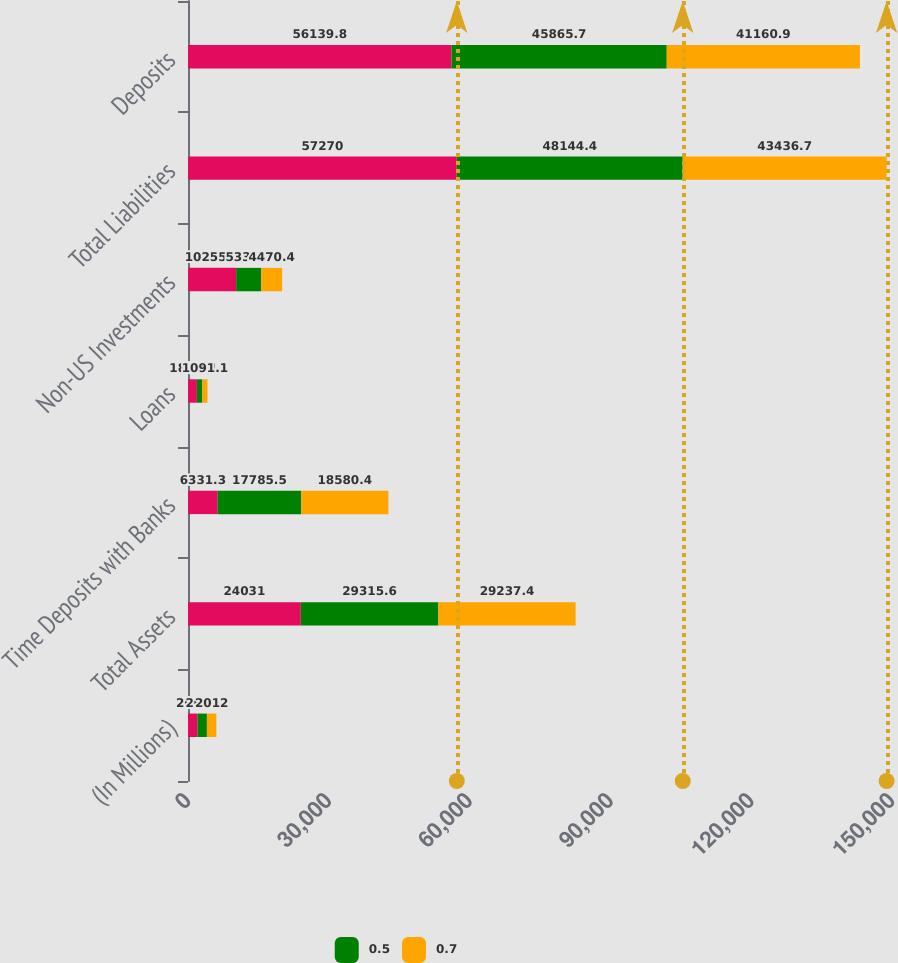Convert chart to OTSL. <chart><loc_0><loc_0><loc_500><loc_500><stacked_bar_chart><ecel><fcel>(In Millions)<fcel>Total Assets<fcel>Time Deposits with Banks<fcel>Loans<fcel>Non-US Investments<fcel>Total Liabilities<fcel>Deposits<nl><fcel>nan<fcel>2016<fcel>24031<fcel>6331.3<fcel>1894.3<fcel>10255.7<fcel>57270<fcel>56139.8<nl><fcel>0.5<fcel>2013<fcel>29315.6<fcel>17785.5<fcel>1164<fcel>5334.1<fcel>48144.4<fcel>45865.7<nl><fcel>0.7<fcel>2012<fcel>29237.4<fcel>18580.4<fcel>1091.1<fcel>4470.4<fcel>43436.7<fcel>41160.9<nl></chart> 